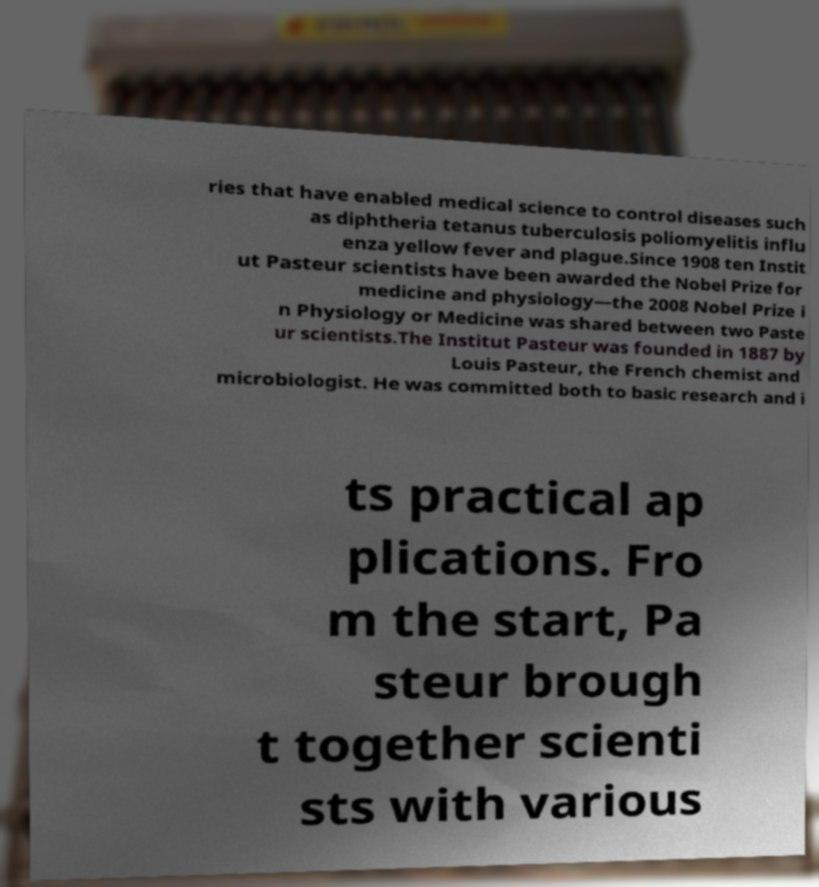Could you extract and type out the text from this image? ries that have enabled medical science to control diseases such as diphtheria tetanus tuberculosis poliomyelitis influ enza yellow fever and plague.Since 1908 ten Instit ut Pasteur scientists have been awarded the Nobel Prize for medicine and physiology—the 2008 Nobel Prize i n Physiology or Medicine was shared between two Paste ur scientists.The Institut Pasteur was founded in 1887 by Louis Pasteur, the French chemist and microbiologist. He was committed both to basic research and i ts practical ap plications. Fro m the start, Pa steur brough t together scienti sts with various 